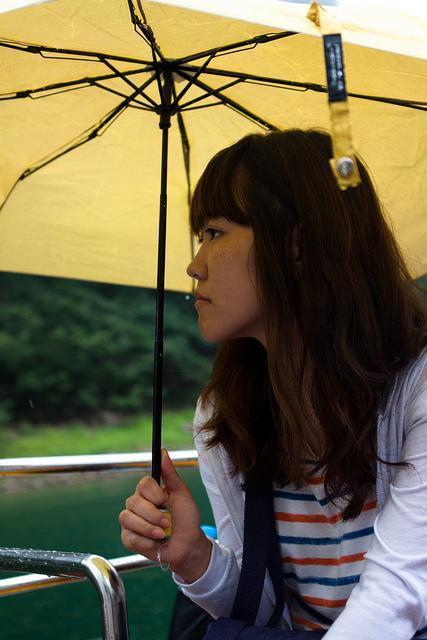How many train tracks are here?
Give a very brief answer. 0. 